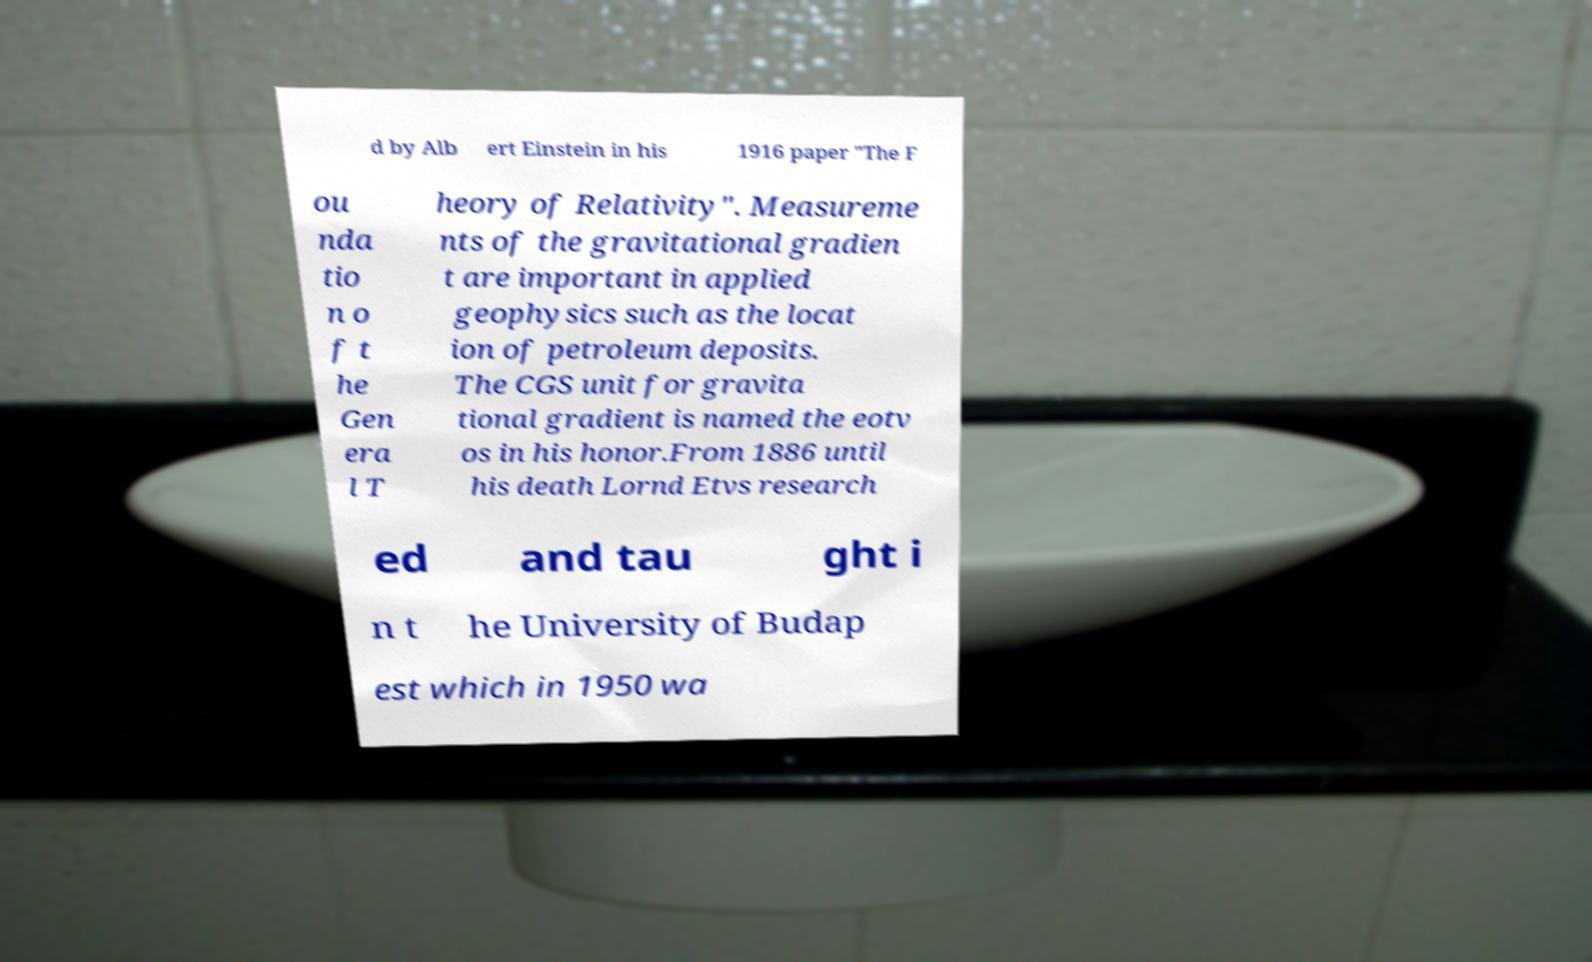Can you accurately transcribe the text from the provided image for me? d by Alb ert Einstein in his 1916 paper "The F ou nda tio n o f t he Gen era l T heory of Relativity". Measureme nts of the gravitational gradien t are important in applied geophysics such as the locat ion of petroleum deposits. The CGS unit for gravita tional gradient is named the eotv os in his honor.From 1886 until his death Lornd Etvs research ed and tau ght i n t he University of Budap est which in 1950 wa 